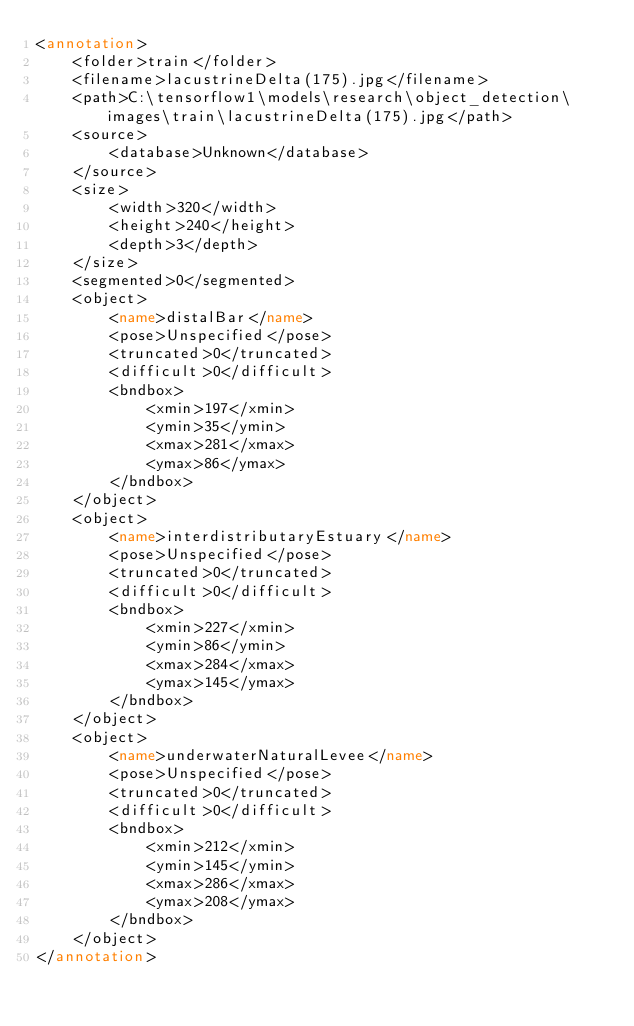<code> <loc_0><loc_0><loc_500><loc_500><_XML_><annotation>
	<folder>train</folder>
	<filename>lacustrineDelta(175).jpg</filename>
	<path>C:\tensorflow1\models\research\object_detection\images\train\lacustrineDelta(175).jpg</path>
	<source>
		<database>Unknown</database>
	</source>
	<size>
		<width>320</width>
		<height>240</height>
		<depth>3</depth>
	</size>
	<segmented>0</segmented>
	<object>
		<name>distalBar</name>
		<pose>Unspecified</pose>
		<truncated>0</truncated>
		<difficult>0</difficult>
		<bndbox>
			<xmin>197</xmin>
			<ymin>35</ymin>
			<xmax>281</xmax>
			<ymax>86</ymax>
		</bndbox>
	</object>
	<object>
		<name>interdistributaryEstuary</name>
		<pose>Unspecified</pose>
		<truncated>0</truncated>
		<difficult>0</difficult>
		<bndbox>
			<xmin>227</xmin>
			<ymin>86</ymin>
			<xmax>284</xmax>
			<ymax>145</ymax>
		</bndbox>
	</object>
	<object>
		<name>underwaterNaturalLevee</name>
		<pose>Unspecified</pose>
		<truncated>0</truncated>
		<difficult>0</difficult>
		<bndbox>
			<xmin>212</xmin>
			<ymin>145</ymin>
			<xmax>286</xmax>
			<ymax>208</ymax>
		</bndbox>
	</object>
</annotation>
</code> 